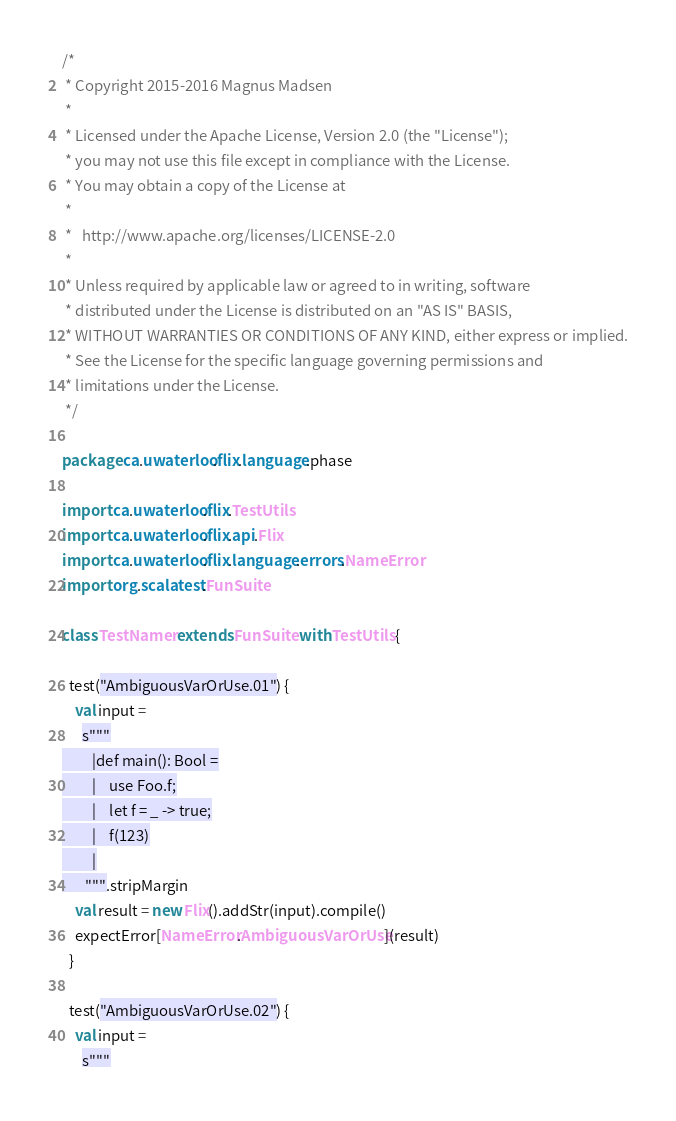<code> <loc_0><loc_0><loc_500><loc_500><_Scala_>/*
 * Copyright 2015-2016 Magnus Madsen
 *
 * Licensed under the Apache License, Version 2.0 (the "License");
 * you may not use this file except in compliance with the License.
 * You may obtain a copy of the License at
 *
 *   http://www.apache.org/licenses/LICENSE-2.0
 *
 * Unless required by applicable law or agreed to in writing, software
 * distributed under the License is distributed on an "AS IS" BASIS,
 * WITHOUT WARRANTIES OR CONDITIONS OF ANY KIND, either express or implied.
 * See the License for the specific language governing permissions and
 * limitations under the License.
 */

package ca.uwaterloo.flix.language.phase

import ca.uwaterloo.flix.TestUtils
import ca.uwaterloo.flix.api.Flix
import ca.uwaterloo.flix.language.errors.NameError
import org.scalatest.FunSuite

class TestNamer extends FunSuite with TestUtils {

  test("AmbiguousVarOrUse.01") {
    val input =
      s"""
         |def main(): Bool =
         |    use Foo.f;
         |    let f = _ -> true;
         |    f(123)
         |
       """.stripMargin
    val result = new Flix().addStr(input).compile()
    expectError[NameError.AmbiguousVarOrUse](result)
  }

  test("AmbiguousVarOrUse.02") {
    val input =
      s"""</code> 